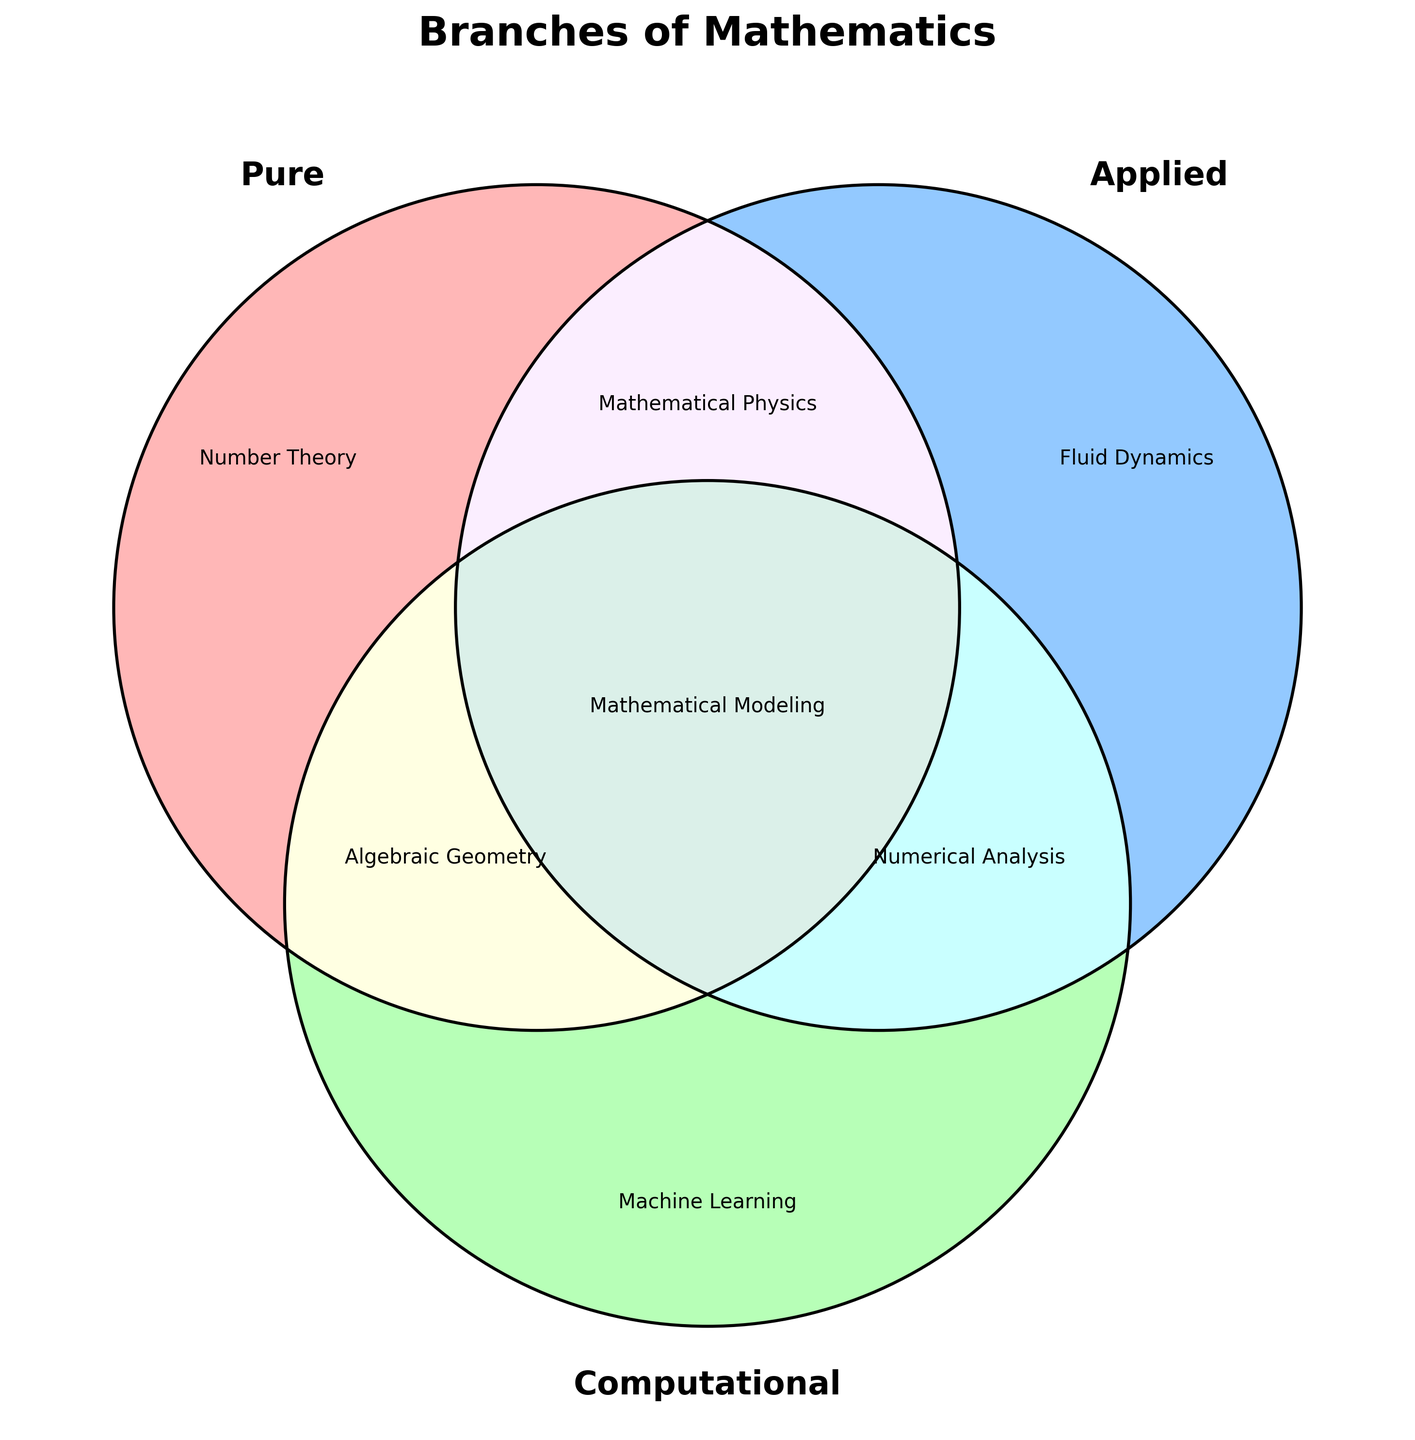What is the title of the Venn Diagram? The title of a plot is usually displayed at the top and often summarizes the purpose or main topic of the figure. In this case, the title "Branches of Mathematics" is clearly indicated at the top of the Venn Diagram.
Answer: Branches of Mathematics Which branch is unique to Pure Mathematics? In a Venn Diagram, areas that do not intersect with any other categories represent unique elements. Here, the area labeled "Pure" contains only "Number Theory", indicating it is unique to Pure Mathematics.
Answer: Number Theory Which branches are common to both Applied and Computational Mathematics but not Pure Mathematics? Venn Diagrams show intersections between different sets. The section where Applied and Computational overlap, but not Pure, is labeled "010", and it contains "Numerical Analysis" and "Scientific Computing", but only the first is visible.
Answer: Numerical Analysis What is the shared branch between Pure and Applied Mathematics but not Computational Mathematics? The intersecting area between Pure and Applied Mathematics only, but not involving Computational Mathematics, is labeled "110". This section contains "Mathematical Physics".
Answer: Mathematical Physics Identify the branch that intersects all three areas: Pure, Applied, and Computational Mathematics. The center of a Venn Diagram, where all three circles intersect, represents elements common to all three sets. This central section labeled "111" contains "Mathematical Modeling".
Answer: Mathematical Modeling Which branch appears uniquely in Computational Mathematics? In a Venn Diagram, areas that do not overlap with other sets represent unique items. The unique section for Computational Mathematics is labeled "001" and contains "Machine Learning".
Answer: Machine Learning How many branches are solely associated with Applied Mathematics? The areas labeled with a single digit "1" representing Applied Mathematics indicate unique branches. Here, the section labeled "010" includes "Fluid Dynamics".
Answer: One Which branch is common to Pure and Computational Mathematics but not to Applied Mathematics? The overlapping section between Pure and Computational Mathematics, excluding Applied Mathematics, is labeled "101"; it includes "Algebraic Geometry".
Answer: Algebraic Geometry What is the shared branch between Applied and Computational Mathematics but not Pure Mathematics? The area where Applied and Computational Mathematics intersect, but not Pure, is labeled "011", and it contains "Data Mining".
Answer: Data Mining 